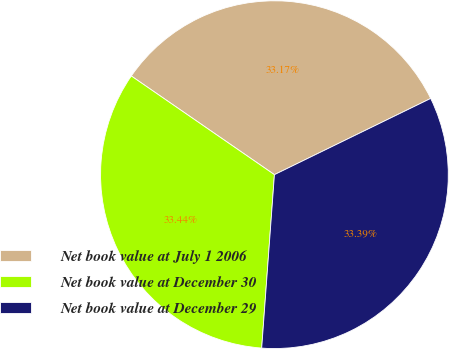Convert chart. <chart><loc_0><loc_0><loc_500><loc_500><pie_chart><fcel>Net book value at July 1 2006<fcel>Net book value at December 30<fcel>Net book value at December 29<nl><fcel>33.17%<fcel>33.44%<fcel>33.39%<nl></chart> 